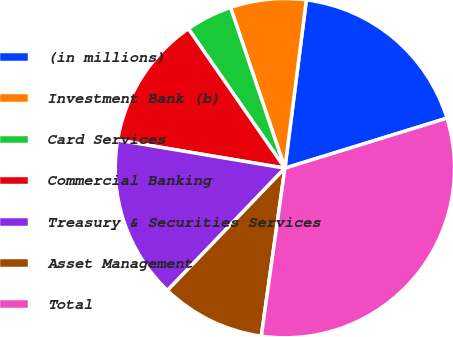Convert chart. <chart><loc_0><loc_0><loc_500><loc_500><pie_chart><fcel>(in millions)<fcel>Investment Bank (b)<fcel>Card Services<fcel>Commercial Banking<fcel>Treasury & Securities Services<fcel>Asset Management<fcel>Total<nl><fcel>18.22%<fcel>7.21%<fcel>4.45%<fcel>12.71%<fcel>15.47%<fcel>9.96%<fcel>31.99%<nl></chart> 